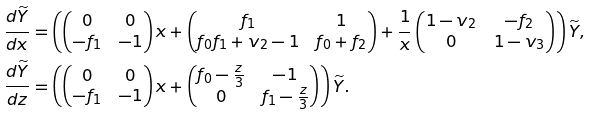<formula> <loc_0><loc_0><loc_500><loc_500>\frac { d \widetilde { Y } } { d x } & = \left ( \begin{pmatrix} 0 & 0 \\ - f _ { 1 } & - 1 \end{pmatrix} x + \begin{pmatrix} f _ { 1 } & 1 \\ f _ { 0 } f _ { 1 } + v _ { 2 } - 1 & f _ { 0 } + f _ { 2 } \end{pmatrix} + \frac { 1 } { x } \begin{pmatrix} 1 - v _ { 2 } & - f _ { 2 } \\ 0 & 1 - v _ { 3 } \end{pmatrix} \right ) \widetilde { Y } , \\ \frac { d \widetilde { Y } } { d z } & = \left ( \begin{pmatrix} 0 & 0 \\ - f _ { 1 } & - 1 \end{pmatrix} x + \begin{pmatrix} f _ { 0 } - \frac { z } { 3 } & - 1 \\ 0 & f _ { 1 } - \frac { z } { 3 } \end{pmatrix} \right ) \widetilde { Y } .</formula> 